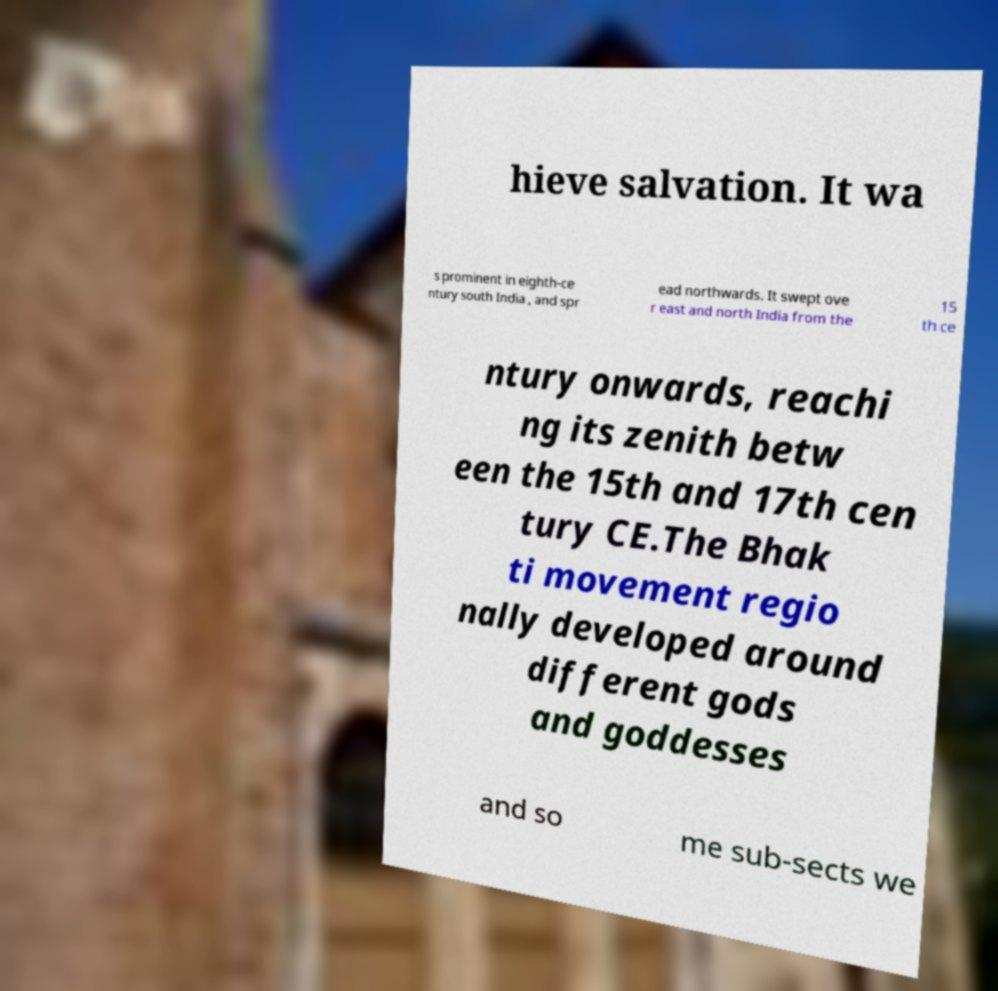What messages or text are displayed in this image? I need them in a readable, typed format. hieve salvation. It wa s prominent in eighth-ce ntury south India , and spr ead northwards. It swept ove r east and north India from the 15 th ce ntury onwards, reachi ng its zenith betw een the 15th and 17th cen tury CE.The Bhak ti movement regio nally developed around different gods and goddesses and so me sub-sects we 